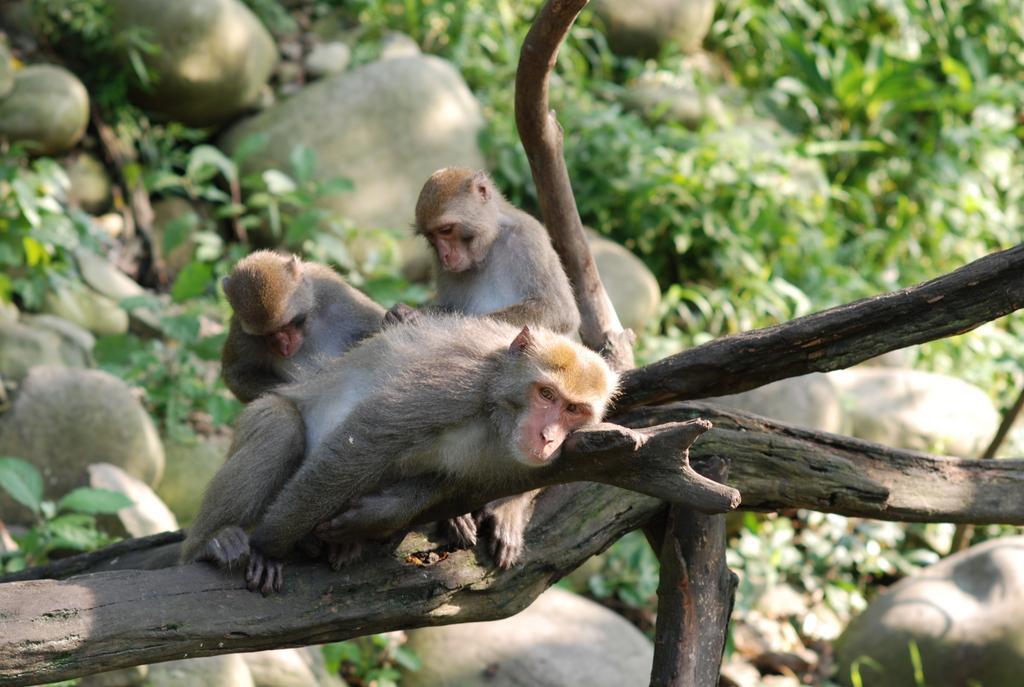Please provide a concise description of this image. In this image there are monkeys on the wooden trunk. Background there are rocks and plants on the land. 